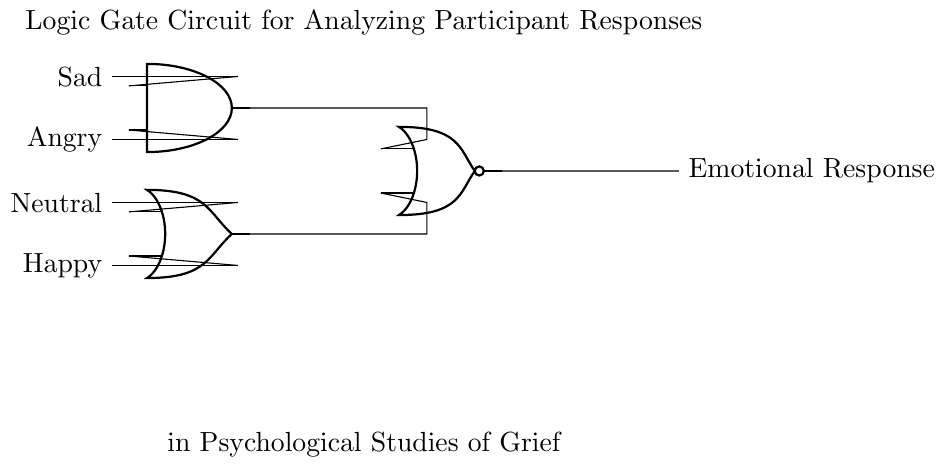What types of inputs are used in this circuit? The inputs are Sad, Angry, Neutral, and Happy emotions, shown clearly on the left side of the circuit.
Answer: Sad, Angry, Neutral, Happy How many gates are present in the first layer? The first layer contains two gates: one AND gate and one OR gate, which are depicted next to the input lines.
Answer: Two What is the function of the AND gate in this circuit? The AND gate processes the Sad and Angry inputs, outputting a signal only if both inputs are high, which is critical for assessing specific emotional conditions in participants.
Answer: Combining emotions What is the output of the NOR gate? The NOR gate receives inputs from both the AND and OR gates, and outputs the final Emotional Response, which reflects the overall emotional state based on the inputs processed.
Answer: Emotional Response What will the output be if all inputs are high? If all inputs (Sad, Angry, Neutral, Happy) are high, the AND gate outputs true, leading the NOR gate to output false, indicating no negative emotional response.
Answer: False Why is the OR gate used in this circuit? The OR gate is crucial because it allows for a positive emotional response when either Neutral or Happy inputs are high, providing insight into less negative emotional states during the study.
Answer: Positive emotional response What is the role of the connections between the gates? The connections between the gates determine how the input signals influence the outputs, allowing for a composite emotional assessment based on multiple responses from participants.
Answer: Determine output 